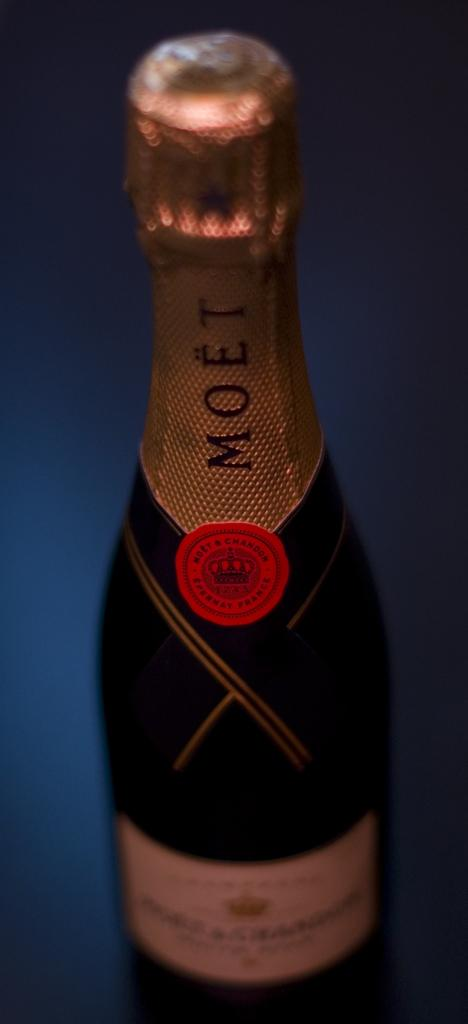<image>
Provide a brief description of the given image. A bottle of Moet wine with a foil wrapper still on it. 